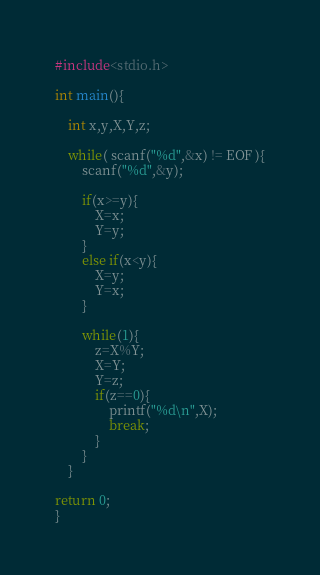<code> <loc_0><loc_0><loc_500><loc_500><_C_>#include<stdio.h>

int main(){
	
	int x,y,X,Y,z;
	
	while( scanf("%d",&x) != EOF ){
		scanf("%d",&y);
		
		if(x>=y){
			X=x;
			Y=y;
		}
		else if(x<y){
			X=y;
			Y=x;
		}
		
		while(1){
			z=X%Y;
			X=Y;
			Y=z;
			if(z==0){
				printf("%d\n",X);
				break;
			}
		}
	}
	
return 0;
}</code> 